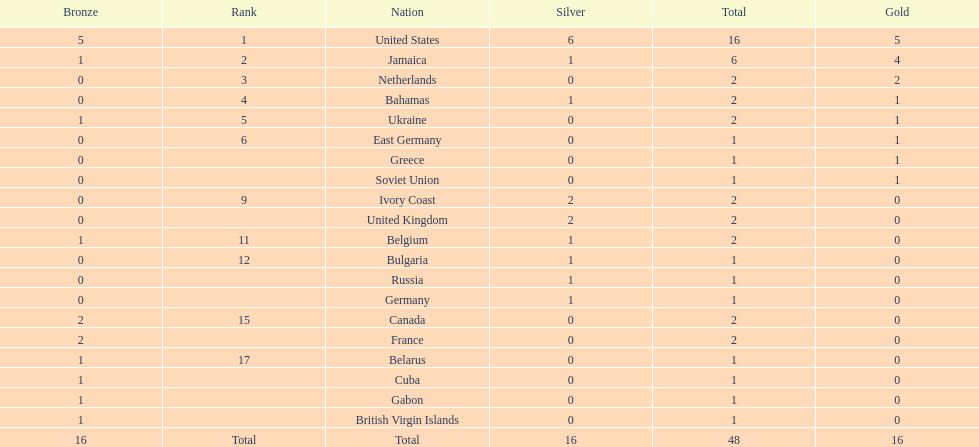How many countries claimed no gold medals? 12. Can you parse all the data within this table? {'header': ['Bronze', 'Rank', 'Nation', 'Silver', 'Total', 'Gold'], 'rows': [['5', '1', 'United States', '6', '16', '5'], ['1', '2', 'Jamaica', '1', '6', '4'], ['0', '3', 'Netherlands', '0', '2', '2'], ['0', '4', 'Bahamas', '1', '2', '1'], ['1', '5', 'Ukraine', '0', '2', '1'], ['0', '6', 'East Germany', '0', '1', '1'], ['0', '', 'Greece', '0', '1', '1'], ['0', '', 'Soviet Union', '0', '1', '1'], ['0', '9', 'Ivory Coast', '2', '2', '0'], ['0', '', 'United Kingdom', '2', '2', '0'], ['1', '11', 'Belgium', '1', '2', '0'], ['0', '12', 'Bulgaria', '1', '1', '0'], ['0', '', 'Russia', '1', '1', '0'], ['0', '', 'Germany', '1', '1', '0'], ['2', '15', 'Canada', '0', '2', '0'], ['2', '', 'France', '0', '2', '0'], ['1', '17', 'Belarus', '0', '1', '0'], ['1', '', 'Cuba', '0', '1', '0'], ['1', '', 'Gabon', '0', '1', '0'], ['1', '', 'British Virgin Islands', '0', '1', '0'], ['16', 'Total', 'Total', '16', '48', '16']]} 